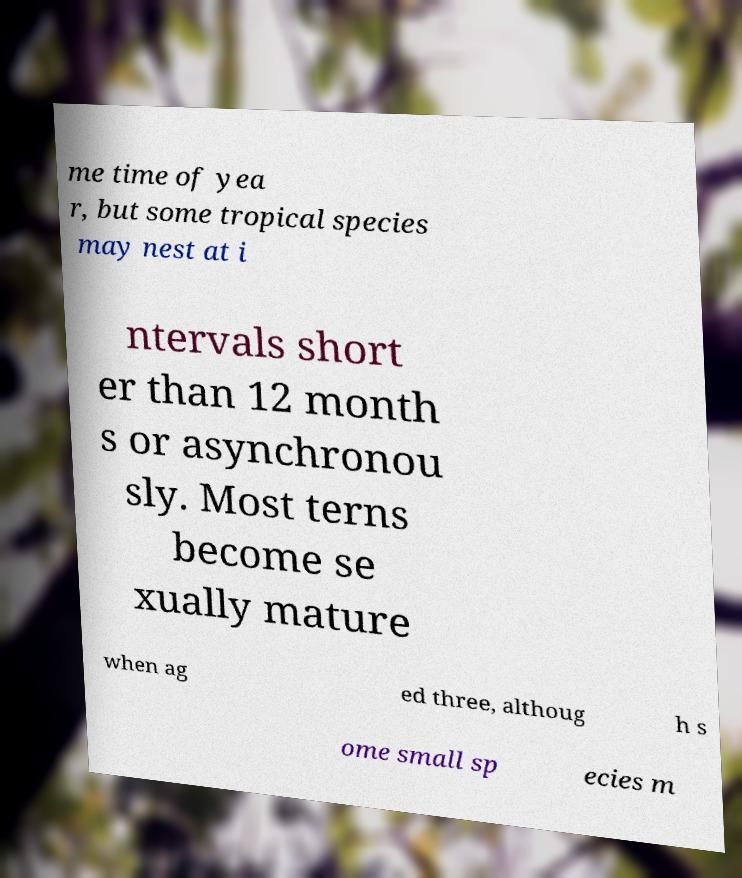Please read and relay the text visible in this image. What does it say? me time of yea r, but some tropical species may nest at i ntervals short er than 12 month s or asynchronou sly. Most terns become se xually mature when ag ed three, althoug h s ome small sp ecies m 